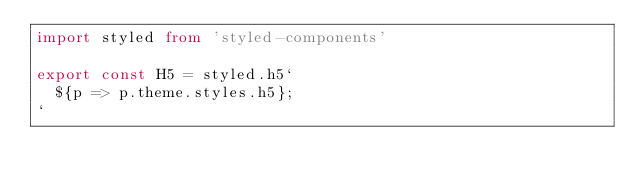<code> <loc_0><loc_0><loc_500><loc_500><_TypeScript_>import styled from 'styled-components'

export const H5 = styled.h5`
  ${p => p.theme.styles.h5};
`
</code> 